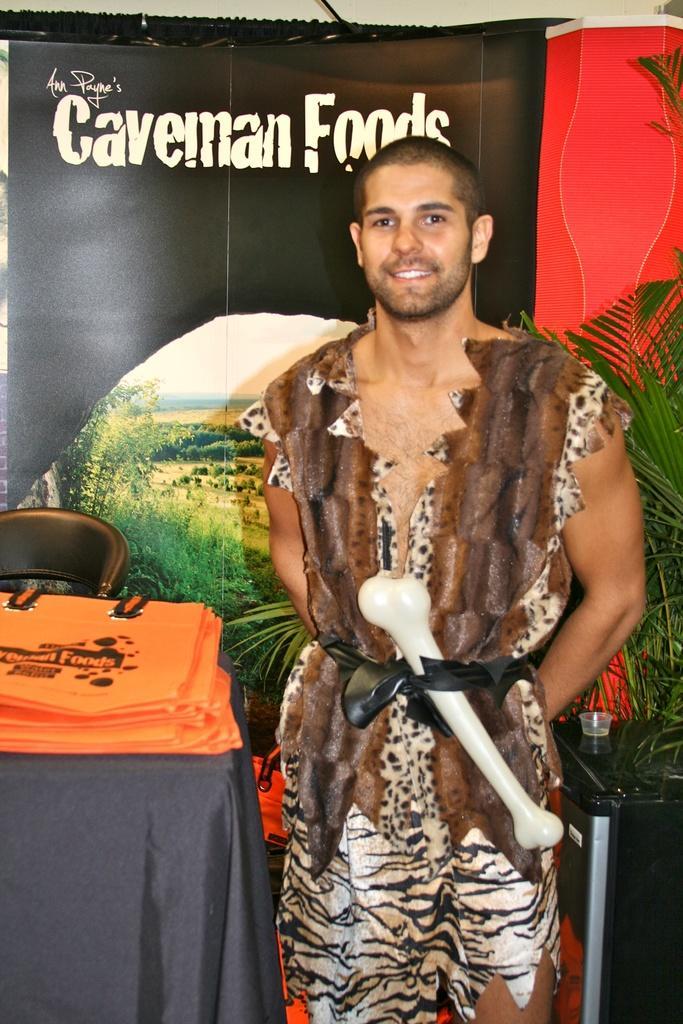How would you summarize this image in a sentence or two? Here we can see a man and he is smiling. This is table. On the table there is a cloth and bags. There is a chair and a plant. In the background there is a banner. 